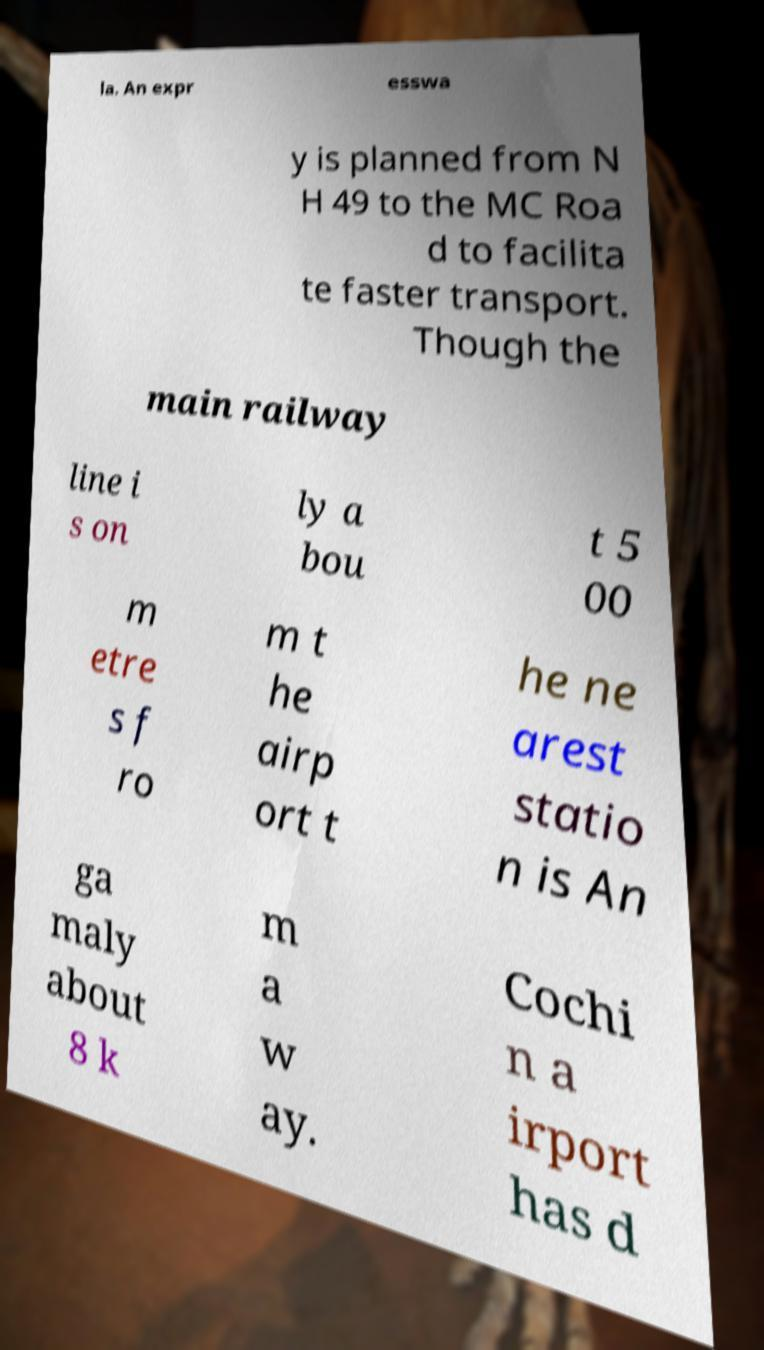For documentation purposes, I need the text within this image transcribed. Could you provide that? la. An expr esswa y is planned from N H 49 to the MC Roa d to facilita te faster transport. Though the main railway line i s on ly a bou t 5 00 m etre s f ro m t he airp ort t he ne arest statio n is An ga maly about 8 k m a w ay. Cochi n a irport has d 